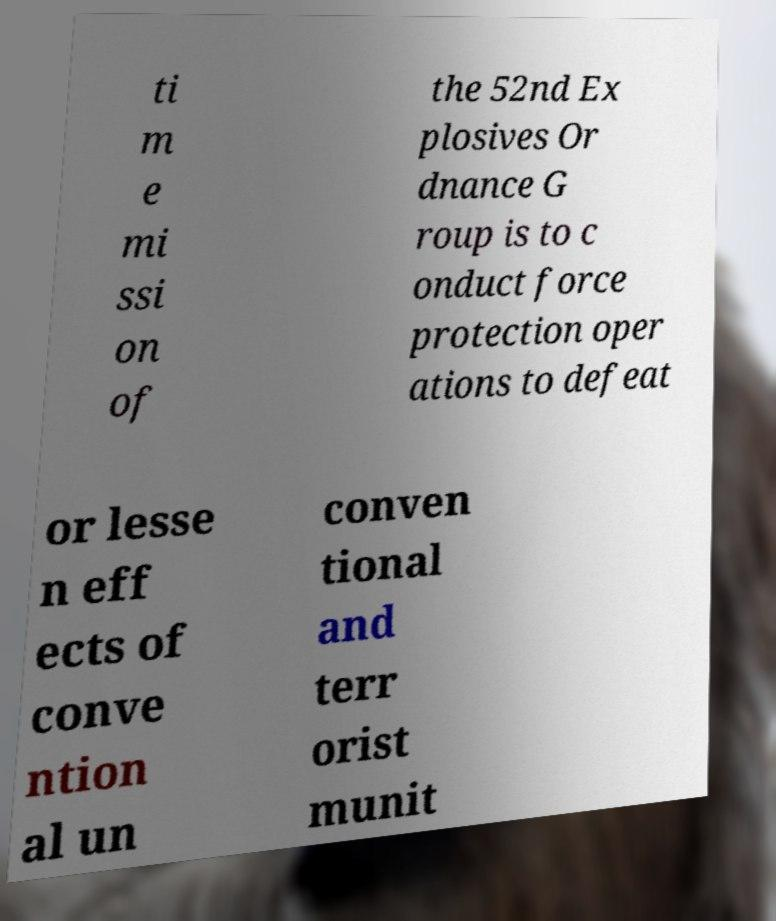There's text embedded in this image that I need extracted. Can you transcribe it verbatim? ti m e mi ssi on of the 52nd Ex plosives Or dnance G roup is to c onduct force protection oper ations to defeat or lesse n eff ects of conve ntion al un conven tional and terr orist munit 